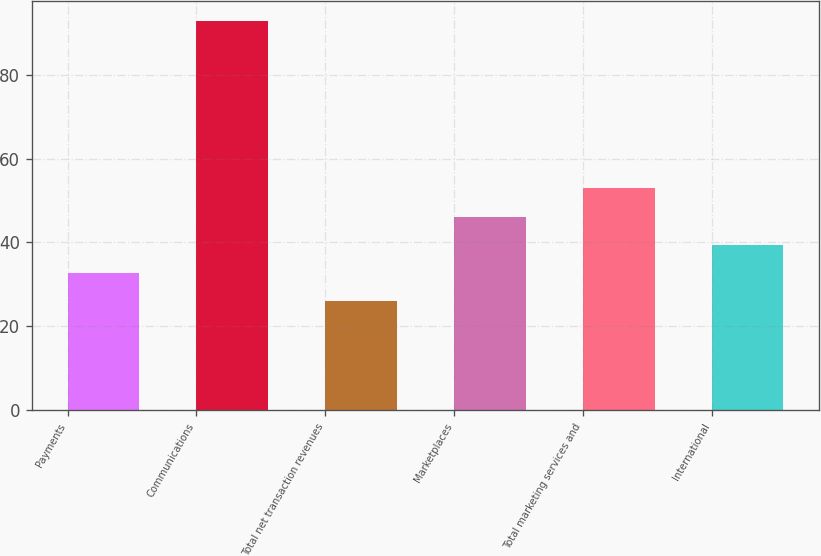Convert chart. <chart><loc_0><loc_0><loc_500><loc_500><bar_chart><fcel>Payments<fcel>Communications<fcel>Total net transaction revenues<fcel>Marketplaces<fcel>Total marketing services and<fcel>International<nl><fcel>32.7<fcel>93<fcel>26<fcel>46.1<fcel>53<fcel>39.4<nl></chart> 